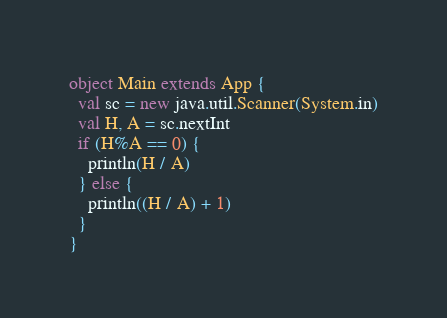Convert code to text. <code><loc_0><loc_0><loc_500><loc_500><_Scala_>object Main extends App {
  val sc = new java.util.Scanner(System.in)
  val H, A = sc.nextInt
  if (H%A == 0) {
    println(H / A)
  } else {
    println((H / A) + 1)
  }
}
</code> 